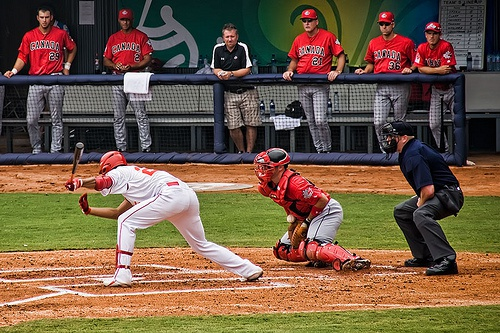Describe the objects in this image and their specific colors. I can see people in black, lightgray, darkgray, lightpink, and brown tones, people in black, gray, navy, and maroon tones, people in black, maroon, brown, and salmon tones, bench in black and gray tones, and people in black, gray, red, and brown tones in this image. 